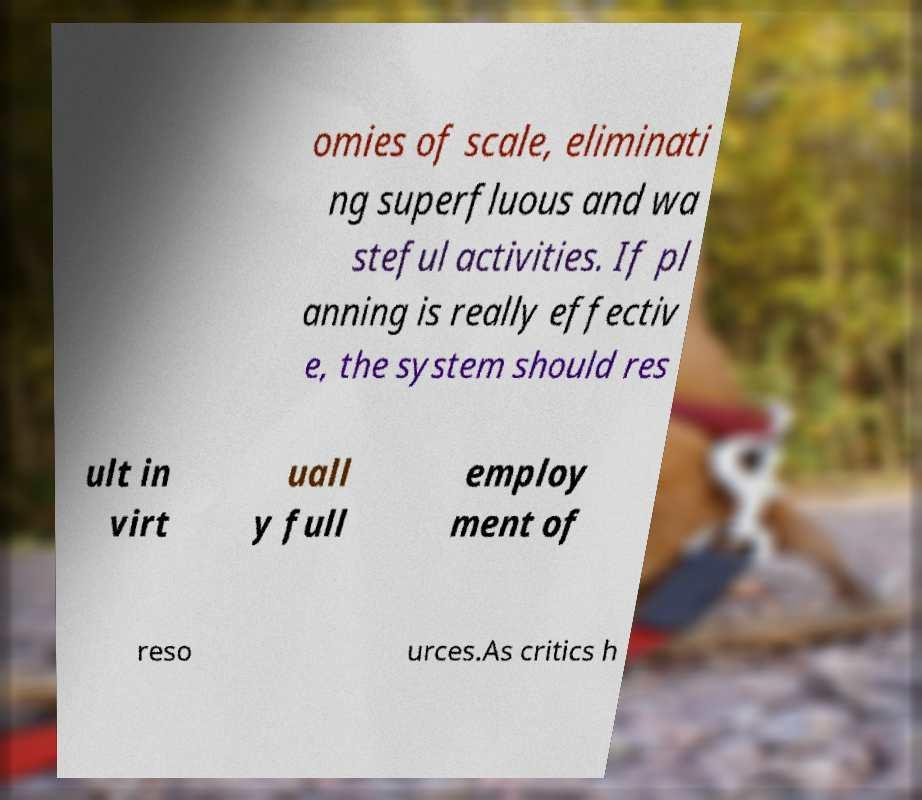For documentation purposes, I need the text within this image transcribed. Could you provide that? omies of scale, eliminati ng superfluous and wa steful activities. If pl anning is really effectiv e, the system should res ult in virt uall y full employ ment of reso urces.As critics h 